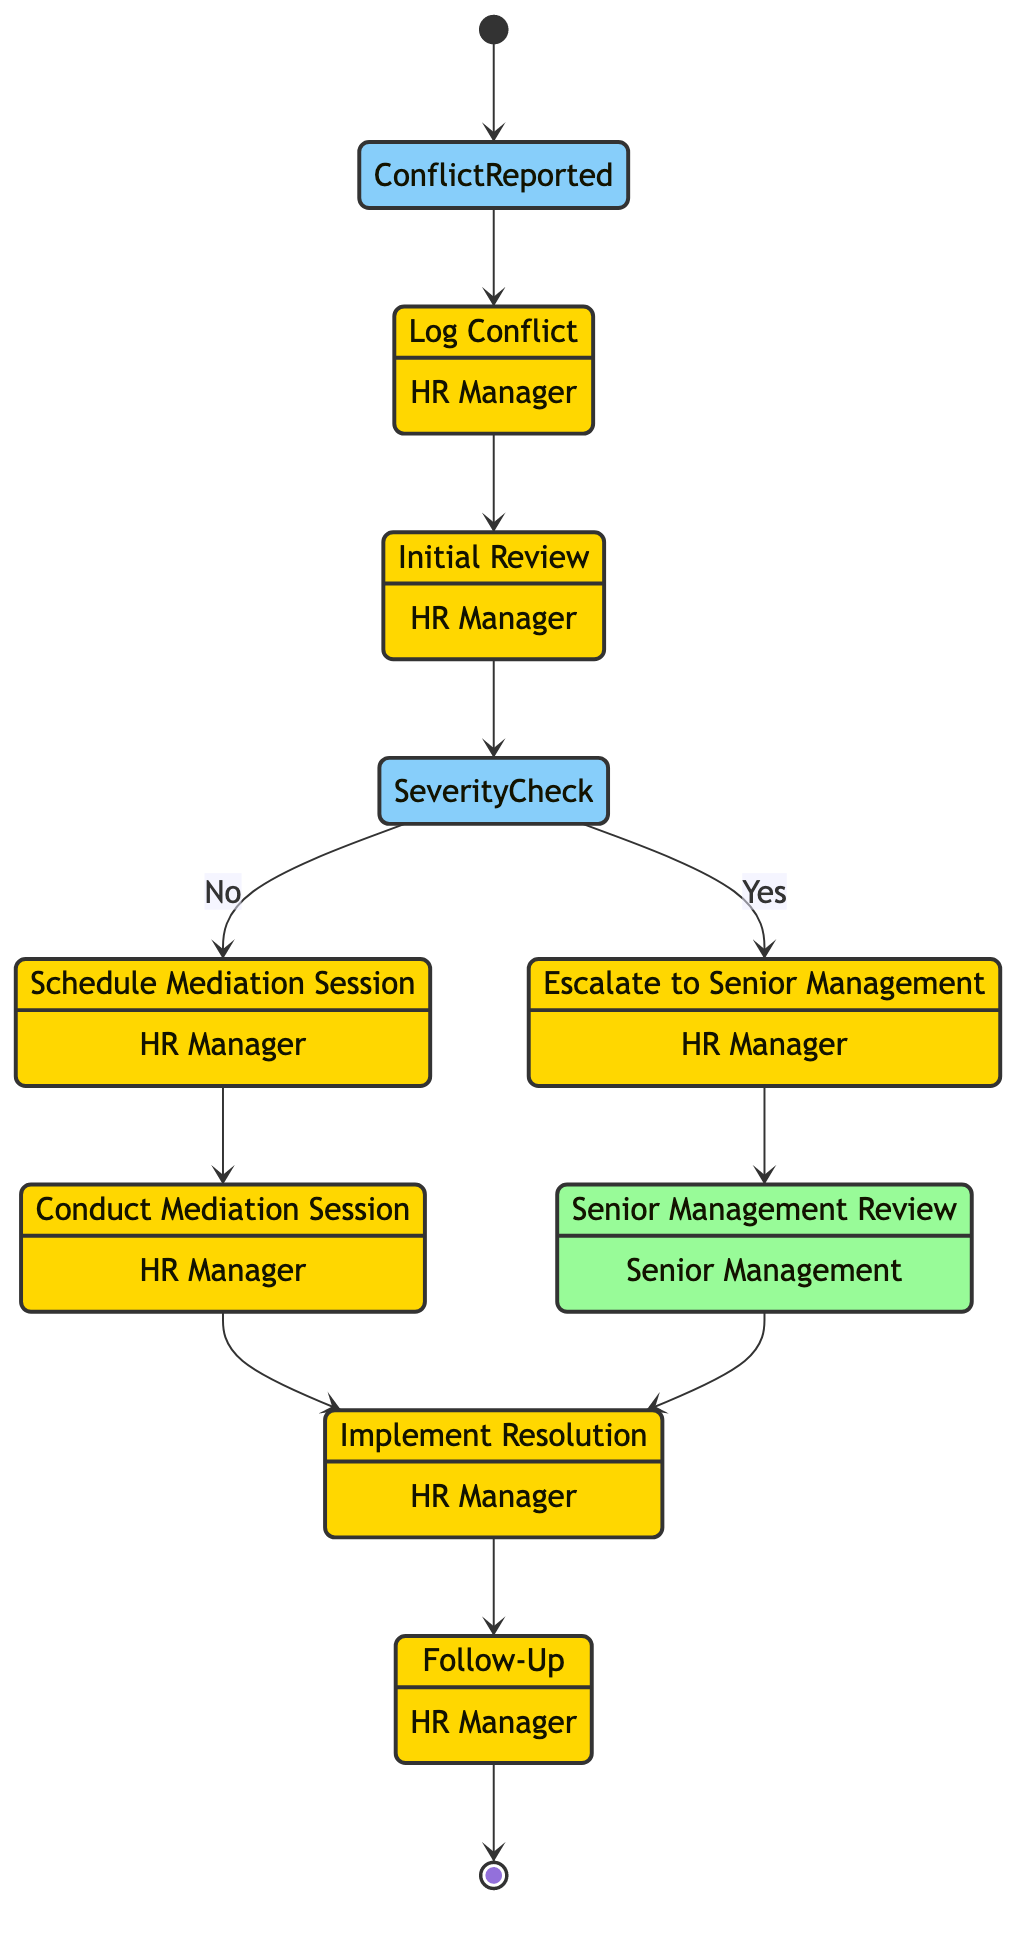What is the first activity in the conflict resolution procedure? The first activity in the diagram is "Log Conflict," which immediately follows the "Conflict Reported" event.
Answer: Log Conflict Who conducts the mediation session? According to the diagram, the "Conduct Mediation Session" activity is performed by the "HR Manager."
Answer: HR Manager How many activities are described in the diagram? The diagram has a total of 8 activities that outline steps in the conflict resolution process.
Answer: 8 What action follows the "Senior Management Review"? Following the "Senior Management Review" in the diagram, the next action is "Implement Resolution."
Answer: Implement Resolution What decision is made at the "Severity Check"? The "Severity Check" node leads to two potential actions based on whether the conflict is severe or not, described as "Yes" for escalating and "No" for mediation scheduling.
Answer: Yes/No What is the last step in the process? The last step described in the diagram is "Follow-Up," which ensures that the conflict is resolved satisfactorily.
Answer: Follow-Up What role is responsible for implementing the resolution? The resolution implementation is the responsibility of the "HR Manager," who takes action based on either the mediation outcome or senior management's decision.
Answer: HR Manager What happens if the conflict is determined to be severe? If the conflict is severe, the flow directs to the "Escalate to Senior Management" activity for further action.
Answer: Escalate to Senior Management 